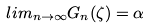Convert formula to latex. <formula><loc_0><loc_0><loc_500><loc_500>l i m _ { n \rightarrow \infty } G _ { n } ( \zeta ) = \alpha</formula> 